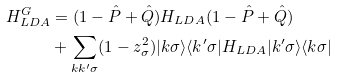Convert formula to latex. <formula><loc_0><loc_0><loc_500><loc_500>H _ { L D A } ^ { G } & = ( 1 - \hat { P } + \hat { Q } ) H _ { L D A } ( 1 - \hat { P } + \hat { Q } ) \\ & + \sum _ { k k ^ { \prime } \sigma } ( 1 - z _ { \sigma } ^ { 2 } ) | k \sigma \rangle \langle k ^ { \prime } \sigma | H _ { L D A } | k ^ { \prime } \sigma \rangle \langle k \sigma |</formula> 